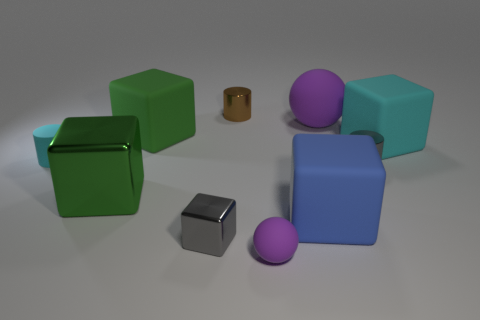Are there any purple matte objects of the same size as the gray block?
Your answer should be compact. Yes. What number of big brown rubber blocks are there?
Your response must be concise. 0. How many large things are cyan rubber objects or blue matte objects?
Offer a terse response. 2. There is a metallic cylinder that is behind the small shiny cylinder to the right of the purple sphere behind the gray cube; what color is it?
Provide a succinct answer. Brown. How many other objects are there of the same color as the matte cylinder?
Your answer should be very brief. 1. How many matte objects are purple spheres or blue things?
Your answer should be compact. 3. Is the color of the large rubber cube that is to the right of the gray shiny cylinder the same as the small metal cylinder in front of the cyan matte cube?
Make the answer very short. No. Are there any other things that have the same material as the large purple thing?
Ensure brevity in your answer.  Yes. There is another object that is the same shape as the big purple object; what is its size?
Your answer should be compact. Small. Is the number of purple balls that are behind the green shiny object greater than the number of big yellow things?
Provide a short and direct response. Yes. 